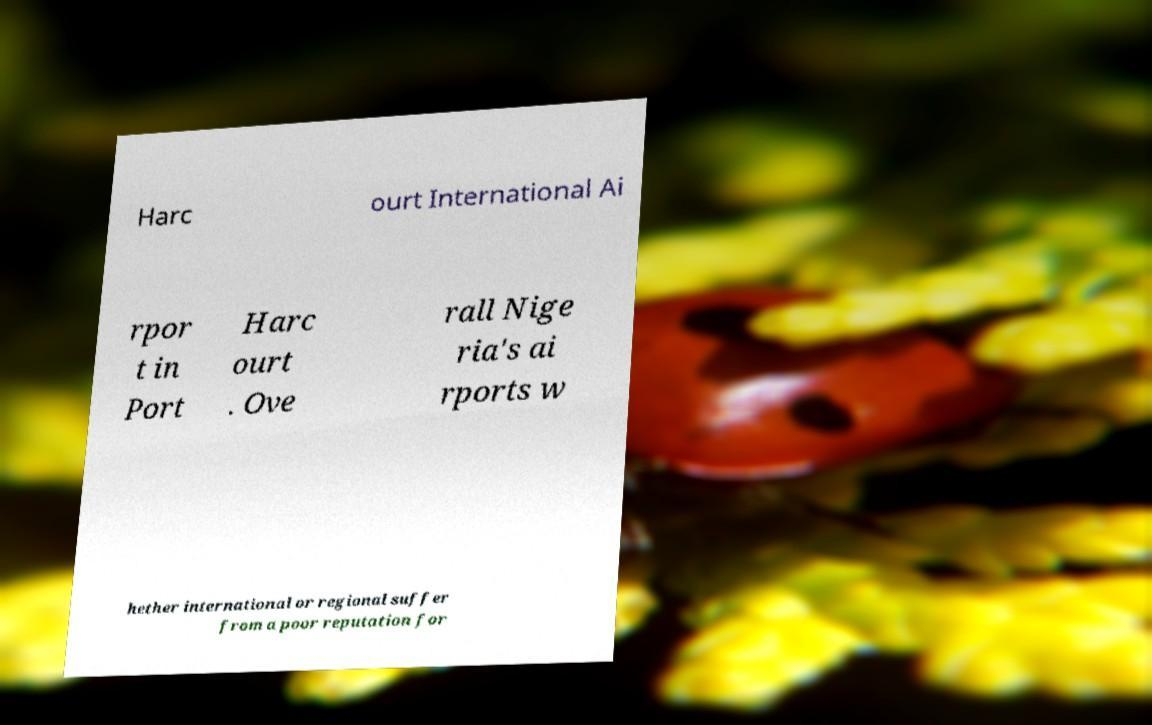There's text embedded in this image that I need extracted. Can you transcribe it verbatim? Harc ourt International Ai rpor t in Port Harc ourt . Ove rall Nige ria's ai rports w hether international or regional suffer from a poor reputation for 